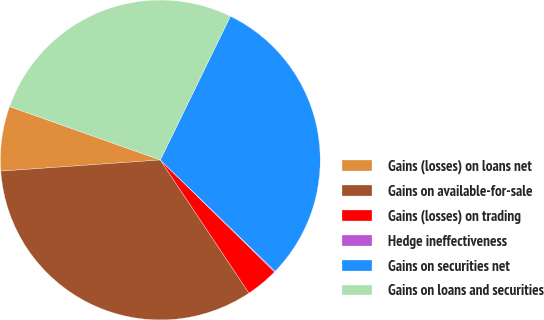Convert chart. <chart><loc_0><loc_0><loc_500><loc_500><pie_chart><fcel>Gains (losses) on loans net<fcel>Gains on available-for-sale<fcel>Gains (losses) on trading<fcel>Hedge ineffectiveness<fcel>Gains on securities net<fcel>Gains on loans and securities<nl><fcel>6.53%<fcel>33.24%<fcel>3.31%<fcel>0.09%<fcel>30.02%<fcel>26.8%<nl></chart> 